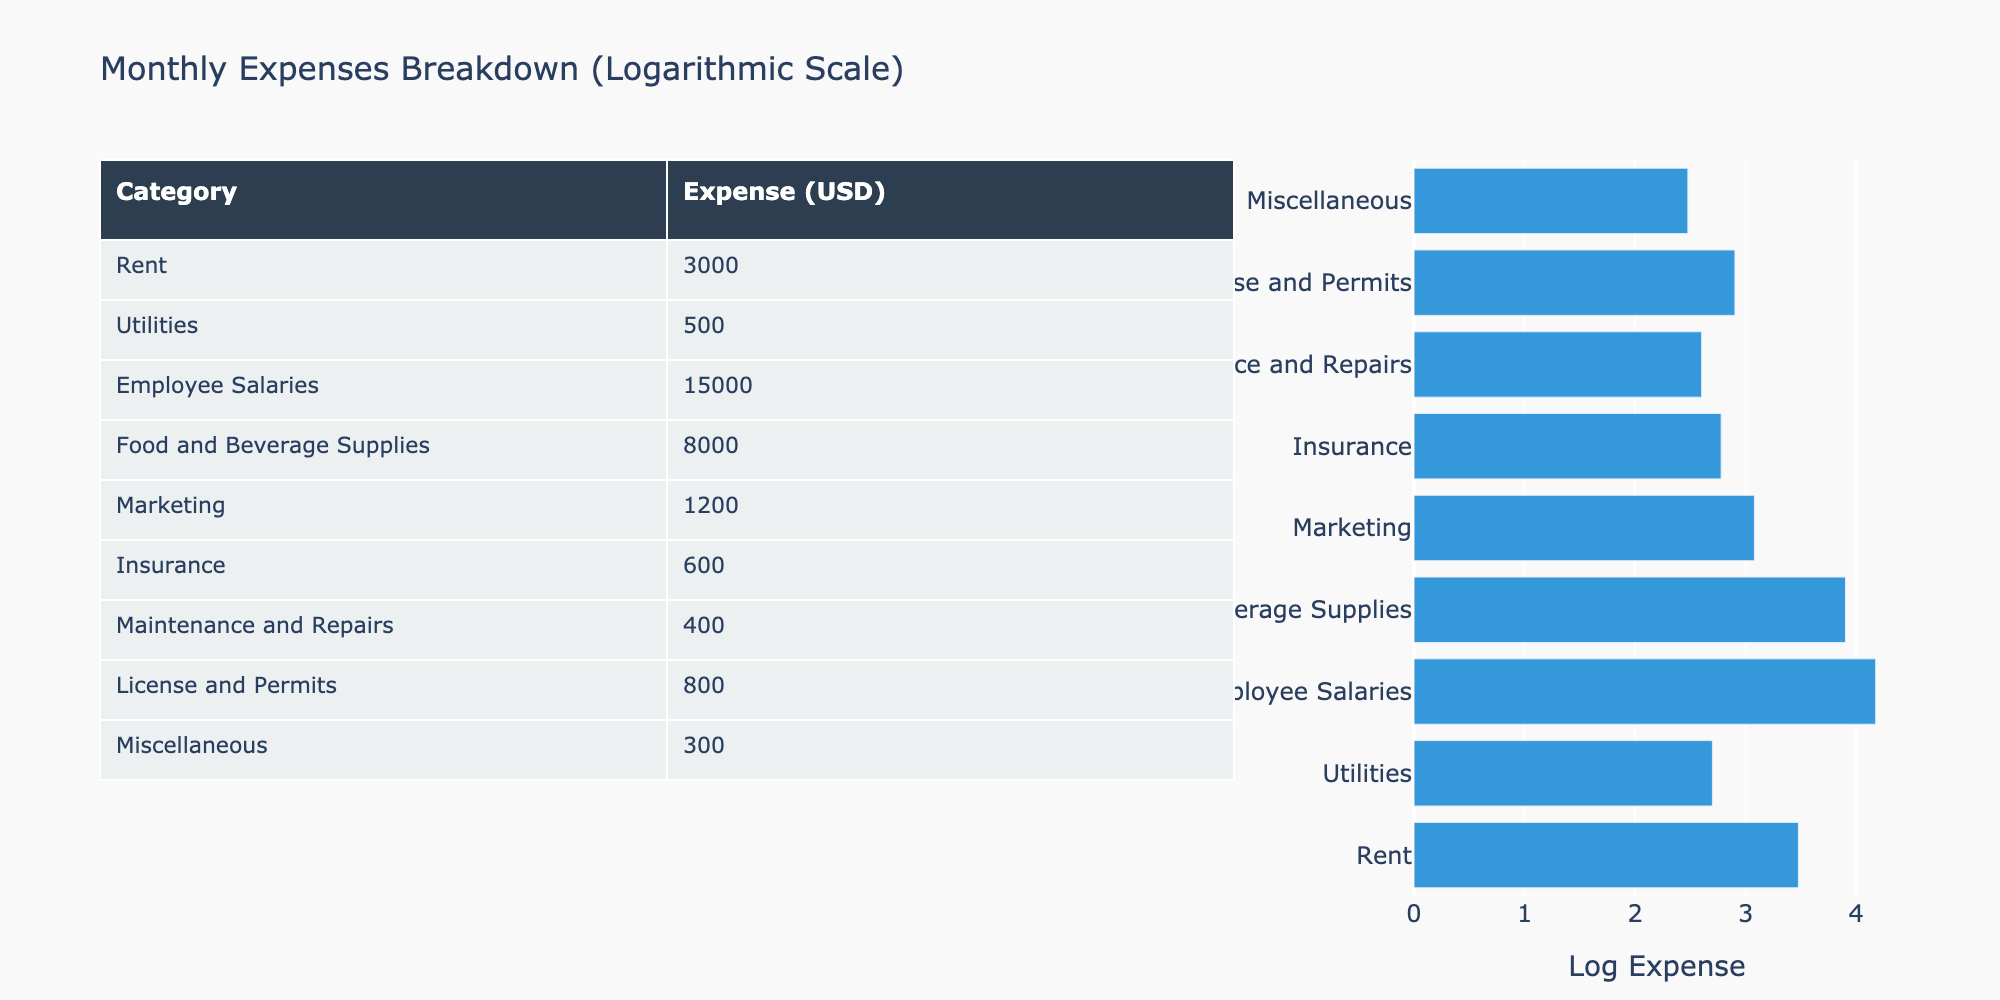What is the total monthly expense for the restaurant? To find the total monthly expense, I need to sum all the expenses listed in the table: 3000 + 500 + 15000 + 8000 + 1200 + 600 + 400 + 800 + 300 = 30000
Answer: 30000 Which category has the highest expense? By reviewing the expenses for each category, I find that Employee Salaries have the highest expense at 15000.
Answer: Employee Salaries Is the expense for Marketing more than the expense for Maintenance and Repairs? The expense for Marketing is 1200, while the expense for Maintenance and Repairs is 400. Since 1200 is greater than 400, the answer is yes.
Answer: Yes What is the average expense across all categories? To calculate the average, I first sum the total expenses which is 30000 as calculated earlier and then divide by the number of categories (9): 30000 / 9 = 3333.33.
Answer: 3333.33 How much more is spent on Food and Beverage Supplies compared to Utilities? The expense for Food and Beverage Supplies is 8000 and for Utilities is 500. To find the difference, I subtract 500 from 8000, which gives 8000 - 500 = 7500.
Answer: 7500 Are the total expenses for Insurance and Utilities less than those for Miscellaneous and Maintenance and Repairs combined? The expenses for Insurance (600) and Utilities (500) summed together are 600 + 500 = 1100. The expenses for Miscellaneous (300) and Maintenance and Repairs (400) summed are 300 + 400 = 700. Since 1100 is greater than 700, the answer is no.
Answer: No What percentage of the total expenses is spent on Rent? The total expenses are 30000, and Rent is 3000. To find the percentage, I calculate (3000 / 30000) * 100, which equals 10%.
Answer: 10% What is the total expense for both Food and Beverage Supplies and Employee Salaries? The expense for Food and Beverage Supplies is 8000 and for Employee Salaries is 15000. By adding these two amounts together, 8000 + 15000 = 23000.
Answer: 23000 Is the overall expense on License and Permits equal to the combination of expenses on Miscellaneous and Maintenance? The expense for License and Permits is 800, while the combined expense for Miscellaneous (300) and Maintenance (400) is 300 + 400 = 700. Since 800 is greater than 700, the answer is no.
Answer: No 